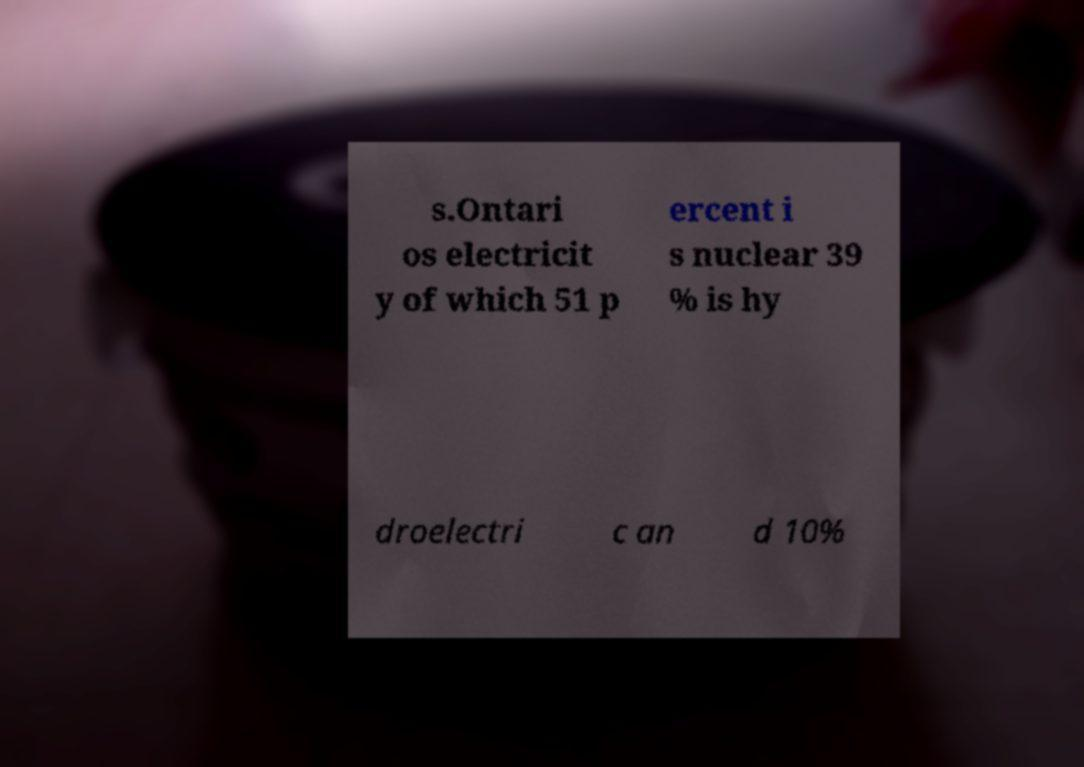Can you read and provide the text displayed in the image?This photo seems to have some interesting text. Can you extract and type it out for me? s.Ontari os electricit y of which 51 p ercent i s nuclear 39 % is hy droelectri c an d 10% 